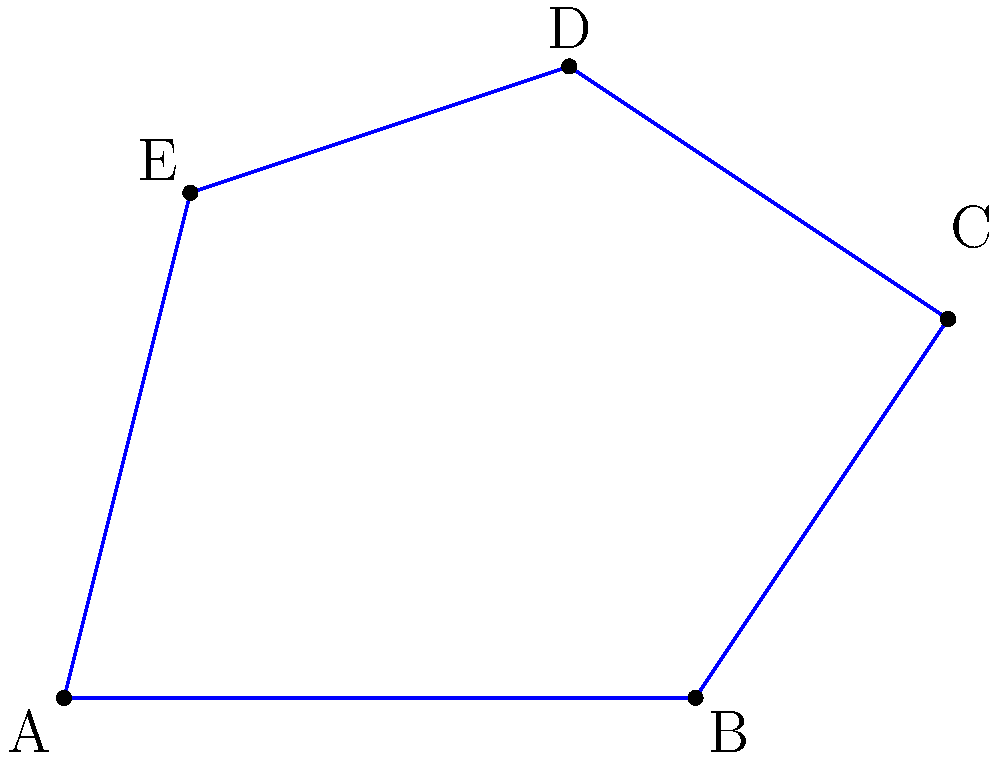A crime scene has an irregular shape as shown in the coordinate system above. The vertices of the crime scene are A(0,0), B(5,0), C(7,3), D(4,5), and E(1,4). Estimate the area of the crime scene using the shoelace formula. Round your answer to the nearest square unit. To estimate the area of the irregular crime scene, we can use the shoelace formula (also known as the surveyor's formula). The steps are as follows:

1) The shoelace formula for a polygon with vertices $(x_1, y_1), (x_2, y_2), ..., (x_n, y_n)$ is:

   Area = $\frac{1}{2}|[(x_1y_2 + x_2y_3 + ... + x_ny_1) - (y_1x_2 + y_2x_3 + ... + y_nx_1)]|$

2) Substitute the given coordinates:
   A(0,0), B(5,0), C(7,3), D(4,5), E(1,4)

3) Apply the formula:

   Area = $\frac{1}{2}|[(0 \cdot 0 + 5 \cdot 3 + 7 \cdot 5 + 4 \cdot 4 + 1 \cdot 0) - (0 \cdot 5 + 0 \cdot 7 + 3 \cdot 4 + 5 \cdot 1 + 4 \cdot 0)]|$

4) Calculate:
   Area = $\frac{1}{2}|[(0 + 15 + 35 + 16 + 0) - (0 + 0 + 12 + 5 + 0)]|$
        = $\frac{1}{2}|[66 - 17]|$
        = $\frac{1}{2}|49|$
        = $\frac{49}{2}$
        = 24.5

5) Round to the nearest square unit:
   24.5 ≈ 25 square units
Answer: 25 square units 